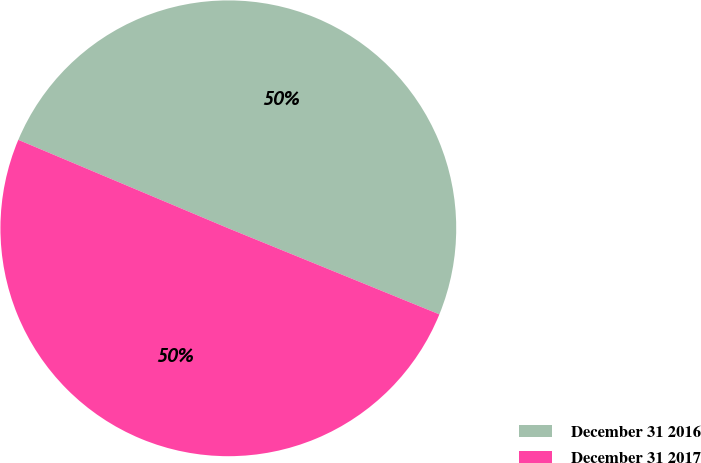<chart> <loc_0><loc_0><loc_500><loc_500><pie_chart><fcel>December 31 2016<fcel>December 31 2017<nl><fcel>49.82%<fcel>50.18%<nl></chart> 